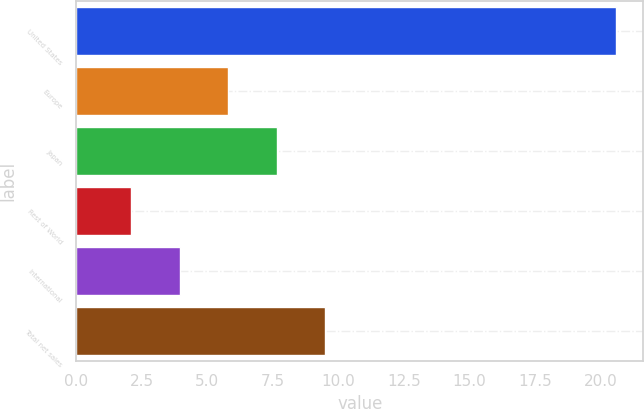Convert chart. <chart><loc_0><loc_0><loc_500><loc_500><bar_chart><fcel>United States<fcel>Europe<fcel>Japan<fcel>Rest of World<fcel>International<fcel>Total net sales<nl><fcel>20.6<fcel>5.8<fcel>7.65<fcel>2.1<fcel>3.95<fcel>9.5<nl></chart> 